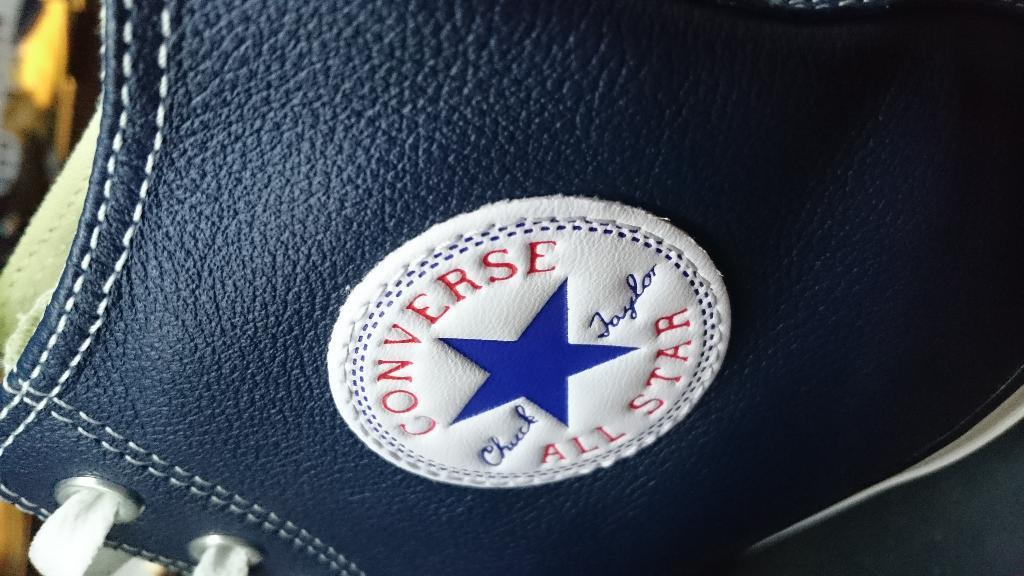What object is present in the image? There is a shoe in the image. What color is the shoe? The shoe is black in color. Can you identify the brand of the shoe? Yes, the shoe has a logo of Converse All Star brand. What type of food is being prepared in the image? There is no food present in the image; it only features a black Converse All Star shoe. 